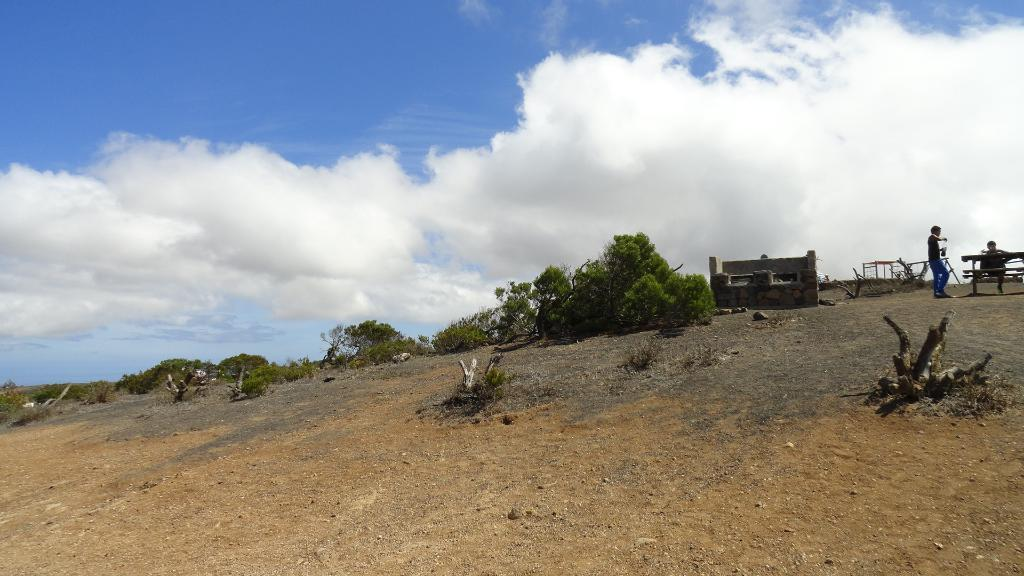What type of material is used for the objects in the image? The objects in the image are made of wood. What type of natural environment is visible in the image? Grass, trees, and the sky are visible in the image. What type of structure is present in the image? There is a wall in the image. What type of furniture is present in the image? There is a table and a bench in the image. Who or what is present in the image? There are people in the image. What type of crate is being used for the class in the image? There is no crate or class present in the image. What type of learning is taking place in the image? There is no learning or educational activity depicted in the image. 